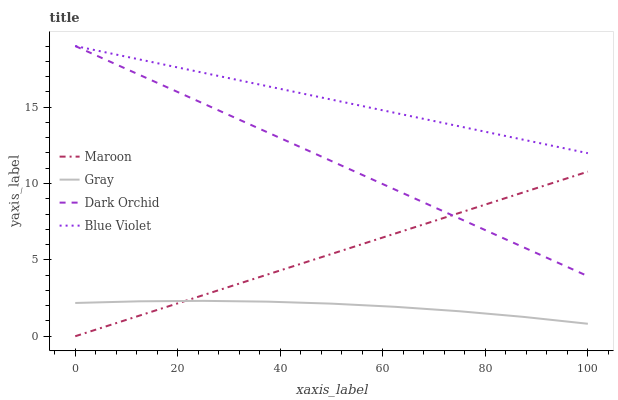Does Gray have the minimum area under the curve?
Answer yes or no. Yes. Does Blue Violet have the maximum area under the curve?
Answer yes or no. Yes. Does Dark Orchid have the minimum area under the curve?
Answer yes or no. No. Does Dark Orchid have the maximum area under the curve?
Answer yes or no. No. Is Maroon the smoothest?
Answer yes or no. Yes. Is Gray the roughest?
Answer yes or no. Yes. Is Dark Orchid the smoothest?
Answer yes or no. No. Is Dark Orchid the roughest?
Answer yes or no. No. Does Gray have the lowest value?
Answer yes or no. No. Does Gray have the highest value?
Answer yes or no. No. Is Gray less than Blue Violet?
Answer yes or no. Yes. Is Blue Violet greater than Maroon?
Answer yes or no. Yes. Does Gray intersect Blue Violet?
Answer yes or no. No. 